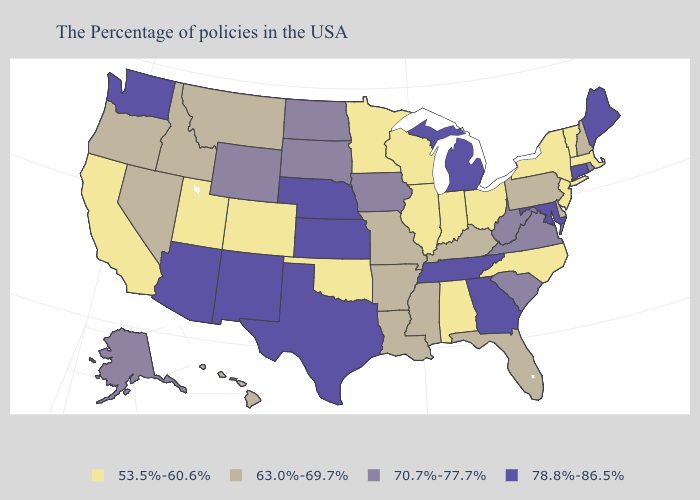Name the states that have a value in the range 53.5%-60.6%?
Be succinct. Massachusetts, Vermont, New York, New Jersey, North Carolina, Ohio, Indiana, Alabama, Wisconsin, Illinois, Minnesota, Oklahoma, Colorado, Utah, California. Does Alabama have a lower value than Hawaii?
Answer briefly. Yes. Does Vermont have a lower value than Oklahoma?
Answer briefly. No. Does Indiana have the highest value in the MidWest?
Concise answer only. No. What is the value of Tennessee?
Concise answer only. 78.8%-86.5%. What is the highest value in states that border Pennsylvania?
Quick response, please. 78.8%-86.5%. Name the states that have a value in the range 70.7%-77.7%?
Write a very short answer. Rhode Island, Virginia, South Carolina, West Virginia, Iowa, South Dakota, North Dakota, Wyoming, Alaska. Does Louisiana have the same value as Nevada?
Write a very short answer. Yes. Name the states that have a value in the range 70.7%-77.7%?
Short answer required. Rhode Island, Virginia, South Carolina, West Virginia, Iowa, South Dakota, North Dakota, Wyoming, Alaska. What is the highest value in states that border Indiana?
Quick response, please. 78.8%-86.5%. Name the states that have a value in the range 70.7%-77.7%?
Be succinct. Rhode Island, Virginia, South Carolina, West Virginia, Iowa, South Dakota, North Dakota, Wyoming, Alaska. What is the value of West Virginia?
Write a very short answer. 70.7%-77.7%. What is the value of Ohio?
Concise answer only. 53.5%-60.6%. Among the states that border Illinois , does Iowa have the lowest value?
Write a very short answer. No. 